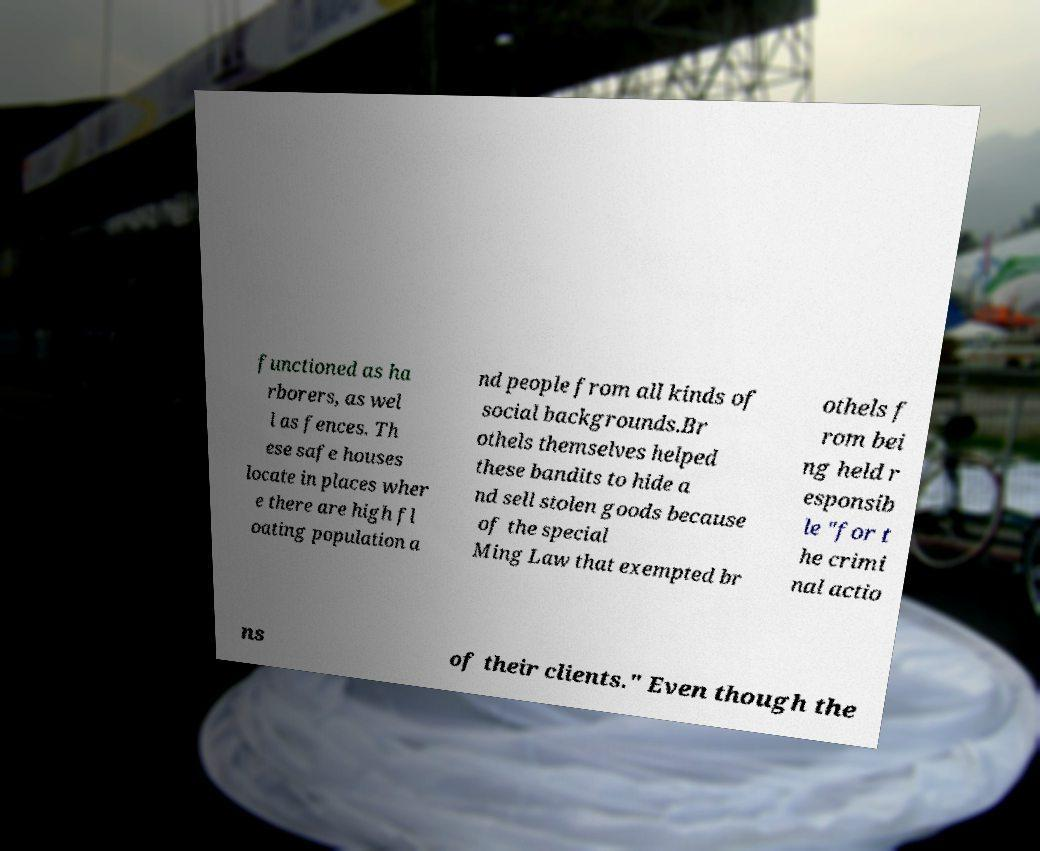Please identify and transcribe the text found in this image. functioned as ha rborers, as wel l as fences. Th ese safe houses locate in places wher e there are high fl oating population a nd people from all kinds of social backgrounds.Br othels themselves helped these bandits to hide a nd sell stolen goods because of the special Ming Law that exempted br othels f rom bei ng held r esponsib le "for t he crimi nal actio ns of their clients." Even though the 